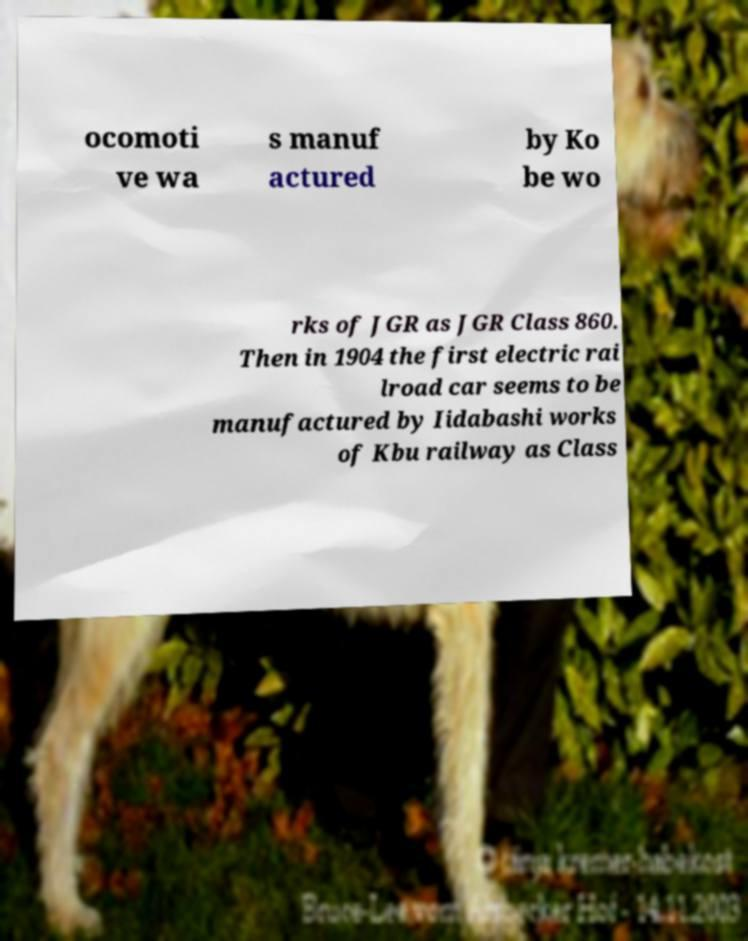For documentation purposes, I need the text within this image transcribed. Could you provide that? ocomoti ve wa s manuf actured by Ko be wo rks of JGR as JGR Class 860. Then in 1904 the first electric rai lroad car seems to be manufactured by Iidabashi works of Kbu railway as Class 